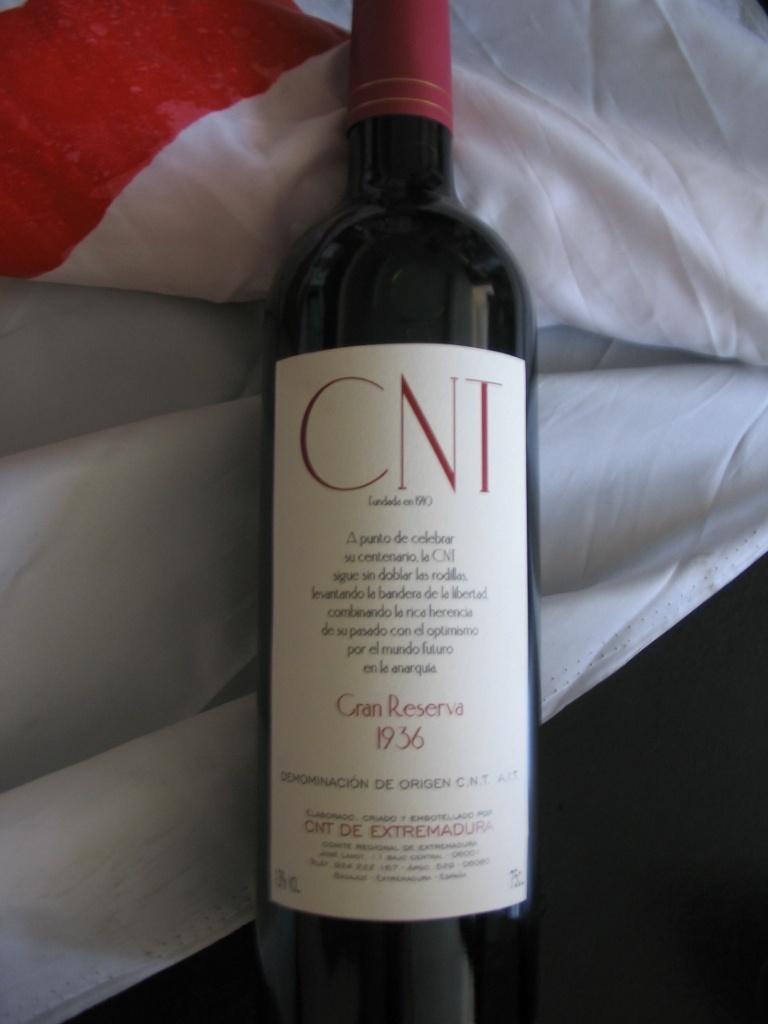What year is this wine from?
Your answer should be compact. 1936. 